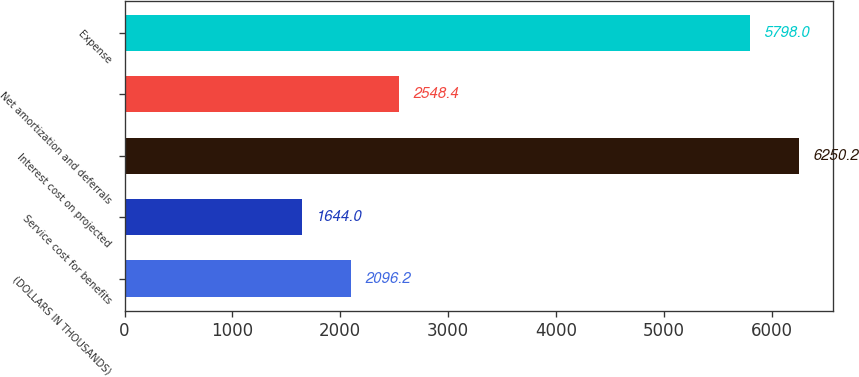Convert chart to OTSL. <chart><loc_0><loc_0><loc_500><loc_500><bar_chart><fcel>(DOLLARS IN THOUSANDS)<fcel>Service cost for benefits<fcel>Interest cost on projected<fcel>Net amortization and deferrals<fcel>Expense<nl><fcel>2096.2<fcel>1644<fcel>6250.2<fcel>2548.4<fcel>5798<nl></chart> 